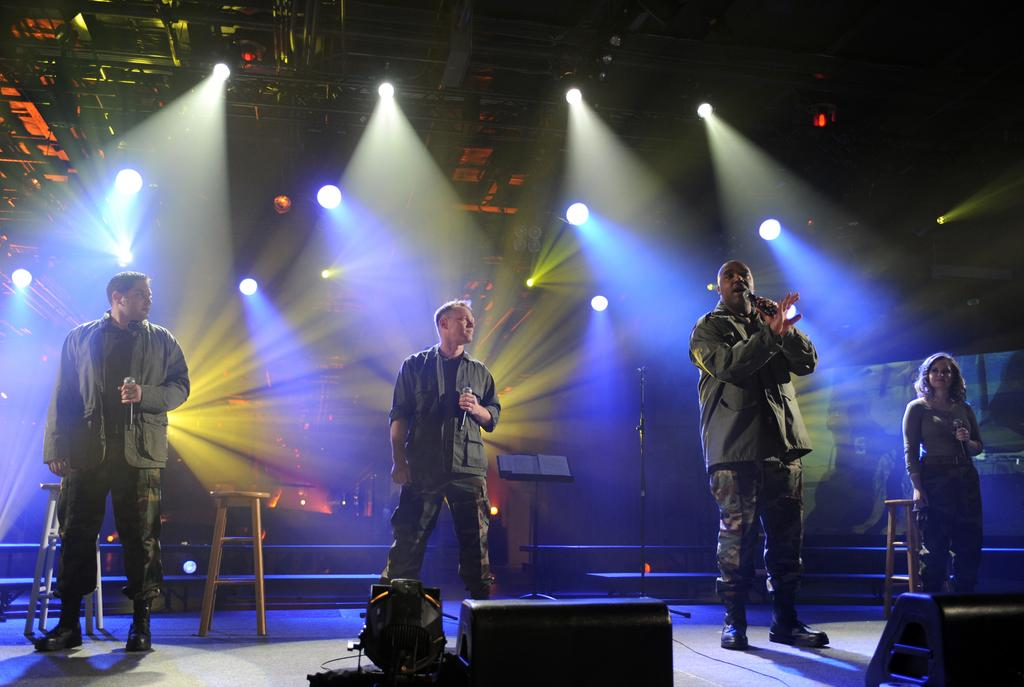What are the people in the image doing? The people in the image are holding microphones, which suggests they might be performing or speaking. What can be seen in the image that might be used for illumination? There are lights visible in the image. What might be used for amplifying sound in the image? There are speakers in the image. What type of seating is present in the image? There are stools in the image. What type of support structures are present in the image? There are stands in the image. Are there any other objects present in the image besides those mentioned? Yes, there are additional objects present in the image. What type of quill is being used to write on the lunch menu in the image? There is no quill or lunch menu present in the image. What type of wind can be seen blowing through the image? There is no wind visible in the image, and the term "zephyr" refers to a gentle breeze, which cannot be seen. 